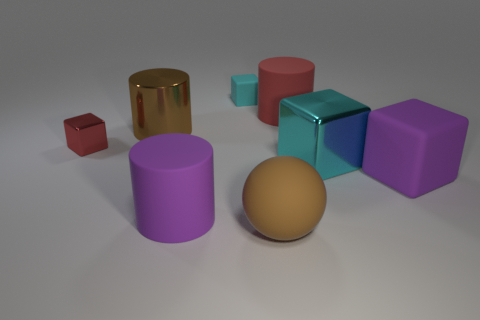What shape is the big object that is both right of the big brown ball and to the left of the big cyan cube?
Give a very brief answer. Cylinder. What number of big things are brown spheres or yellow blocks?
Give a very brief answer. 1. Are there an equal number of cubes that are behind the large purple cube and cubes that are in front of the large brown shiny cylinder?
Offer a very short reply. Yes. What number of other things are there of the same color as the ball?
Offer a terse response. 1. Are there an equal number of shiny cylinders that are to the right of the big red rubber thing and tiny purple shiny spheres?
Offer a very short reply. Yes. Do the brown metallic thing and the brown matte ball have the same size?
Make the answer very short. Yes. There is a cube that is both left of the big brown sphere and on the right side of the tiny red metal object; what material is it?
Your answer should be very brief. Rubber. What number of red objects have the same shape as the cyan matte thing?
Your answer should be compact. 1. There is a brown object that is behind the large brown ball; what material is it?
Keep it short and to the point. Metal. Is the number of rubber things that are on the right side of the brown rubber object less than the number of big brown metal objects?
Make the answer very short. No. 